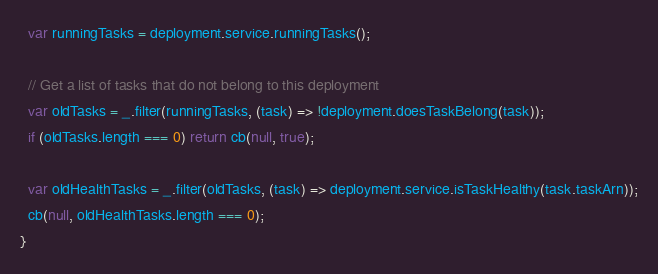Convert code to text. <code><loc_0><loc_0><loc_500><loc_500><_JavaScript_>  var runningTasks = deployment.service.runningTasks();

  // Get a list of tasks that do not belong to this deployment
  var oldTasks = _.filter(runningTasks, (task) => !deployment.doesTaskBelong(task));
  if (oldTasks.length === 0) return cb(null, true);

  var oldHealthTasks = _.filter(oldTasks, (task) => deployment.service.isTaskHealthy(task.taskArn));
  cb(null, oldHealthTasks.length === 0);
}
</code> 